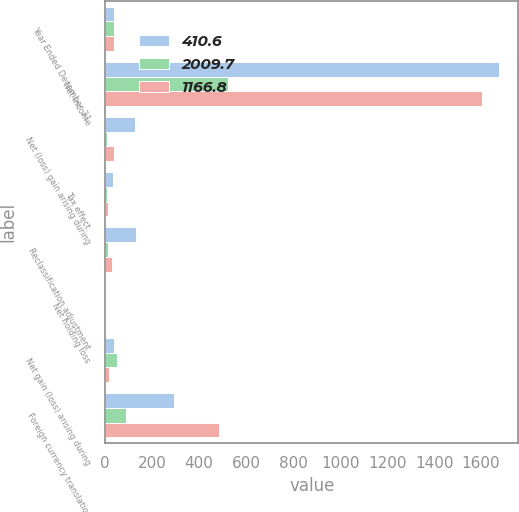Convert chart to OTSL. <chart><loc_0><loc_0><loc_500><loc_500><stacked_bar_chart><ecel><fcel>Year Ended December 31<fcel>Net income<fcel>Net (loss) gain arising during<fcel>Tax effect<fcel>Reclassification adjustment<fcel>Net holding loss<fcel>Net gain (loss) arising during<fcel>Foreign currency translation<nl><fcel>410.6<fcel>37.1<fcel>1675.2<fcel>125.5<fcel>33.9<fcel>133.4<fcel>1.5<fcel>37.1<fcel>292<nl><fcel>2009.7<fcel>37.1<fcel>521.7<fcel>6.5<fcel>6.7<fcel>10.8<fcel>0.1<fcel>50.3<fcel>87.1<nl><fcel>1166.8<fcel>37.1<fcel>1604<fcel>38.7<fcel>10.8<fcel>29.3<fcel>2.3<fcel>17.7<fcel>483.8<nl></chart> 